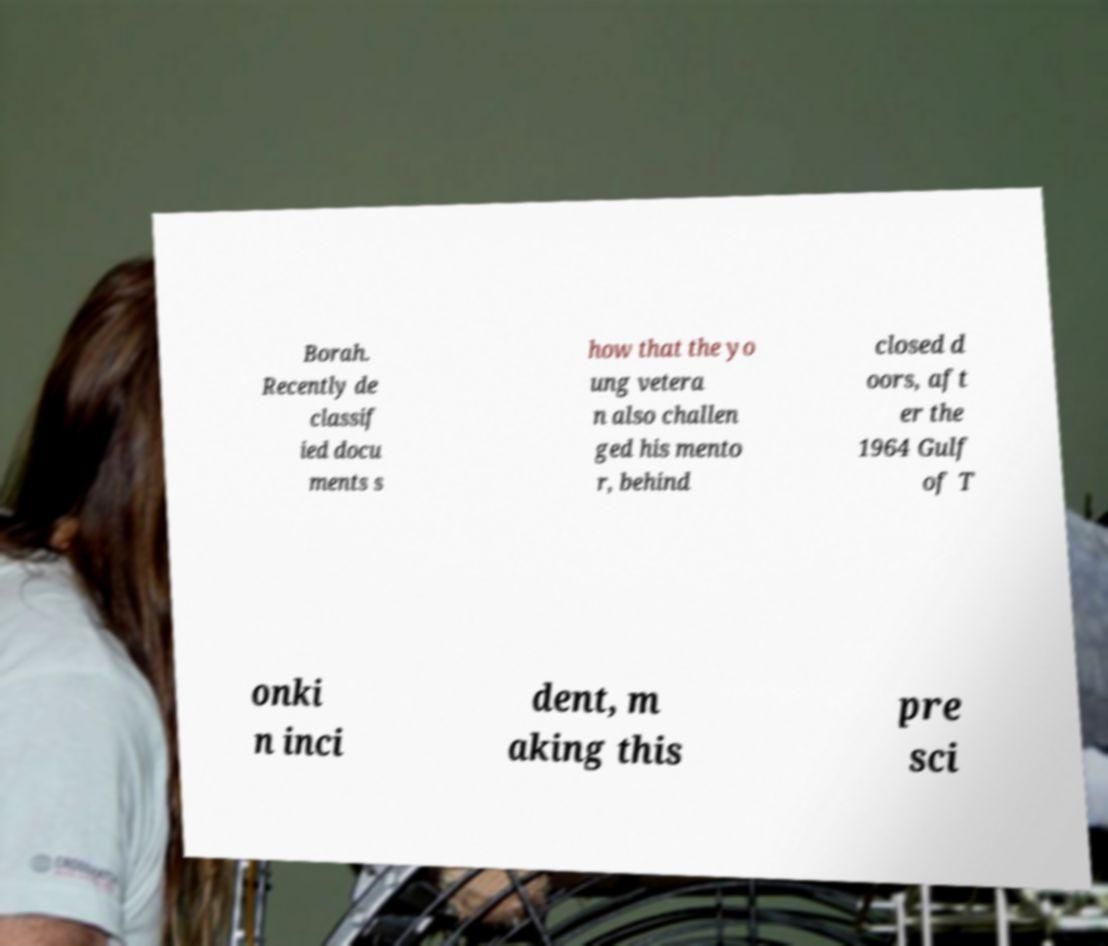Can you accurately transcribe the text from the provided image for me? Borah. Recently de classif ied docu ments s how that the yo ung vetera n also challen ged his mento r, behind closed d oors, aft er the 1964 Gulf of T onki n inci dent, m aking this pre sci 